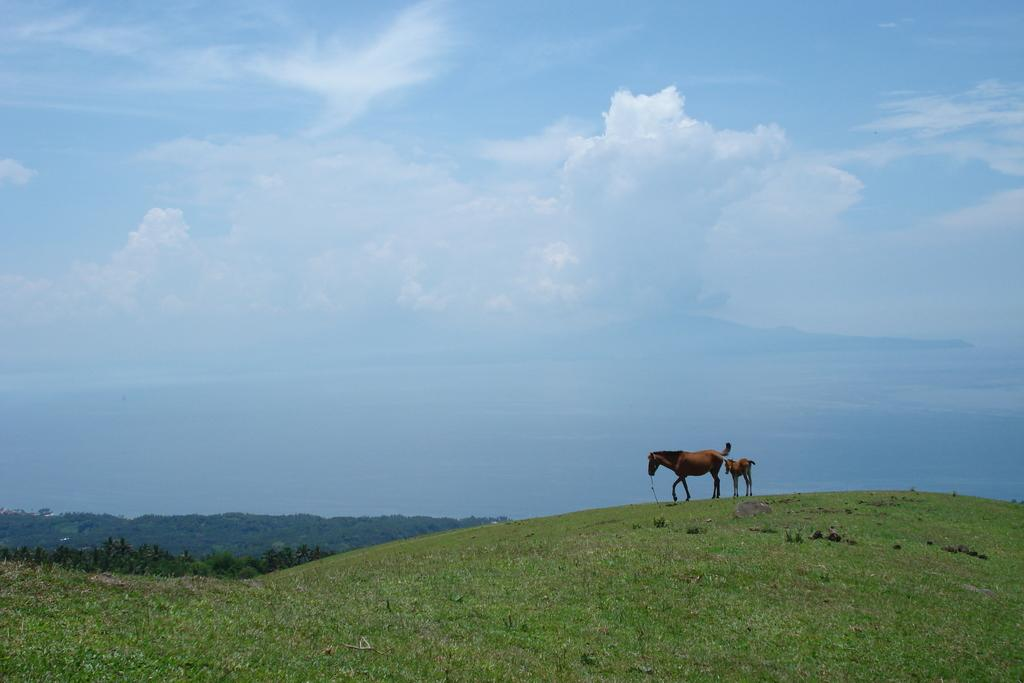What type of animals can be seen on the ground in the image? There are animals on the ground in the image, but their specific type is not mentioned in the facts. What type of vegetation is visible in the image? There is grass visible in the image, and there are also trees present. What is visible in the background of the image? The sky is visible in the background of the image. What can be seen in the sky? Clouds are present in the sky. What type of news can be seen on the bedroom wall in the image? There is no mention of a bedroom or news in the image; it features animals, grass, trees, and a sky with clouds. 